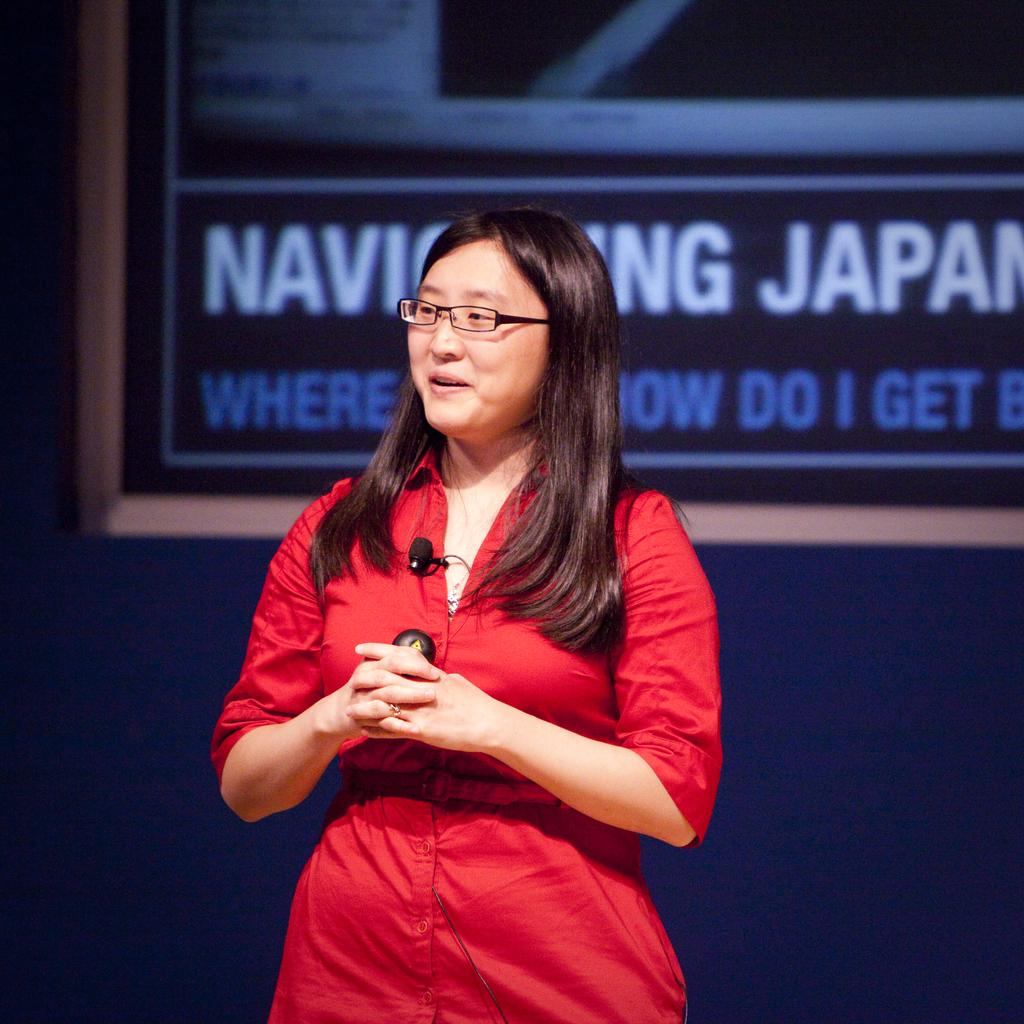Who is present in the image? There is a woman in the image. What is the woman's facial expression? The woman is smiling. What accessory is the woman wearing? The woman is wearing spectacles. What can be seen in the background of the image? There is a board visible in the background of the image. What flavor of oven can be seen in the image? There is no oven present in the image, so it is not possible to determine the flavor. 